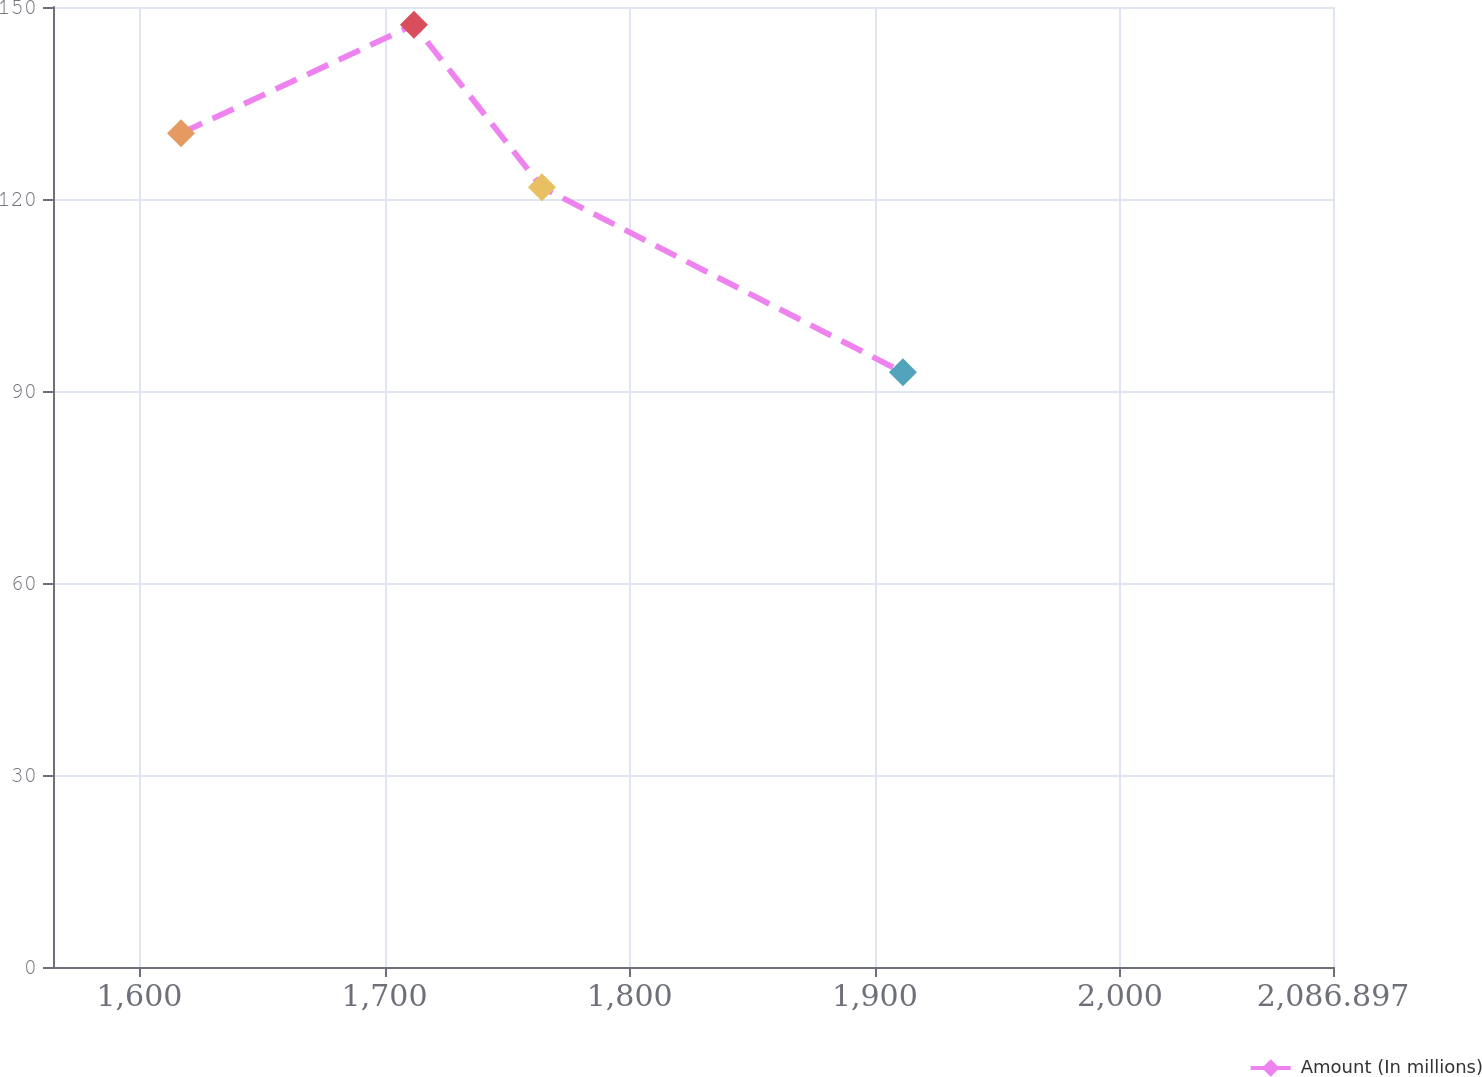Convert chart. <chart><loc_0><loc_0><loc_500><loc_500><line_chart><ecel><fcel>Amount (In millions)<nl><fcel>1616.98<fcel>130.27<nl><fcel>1712<fcel>147.21<nl><fcel>1764.21<fcel>121.82<nl><fcel>1911.46<fcel>92.92<nl><fcel>2139.11<fcel>98.35<nl></chart> 